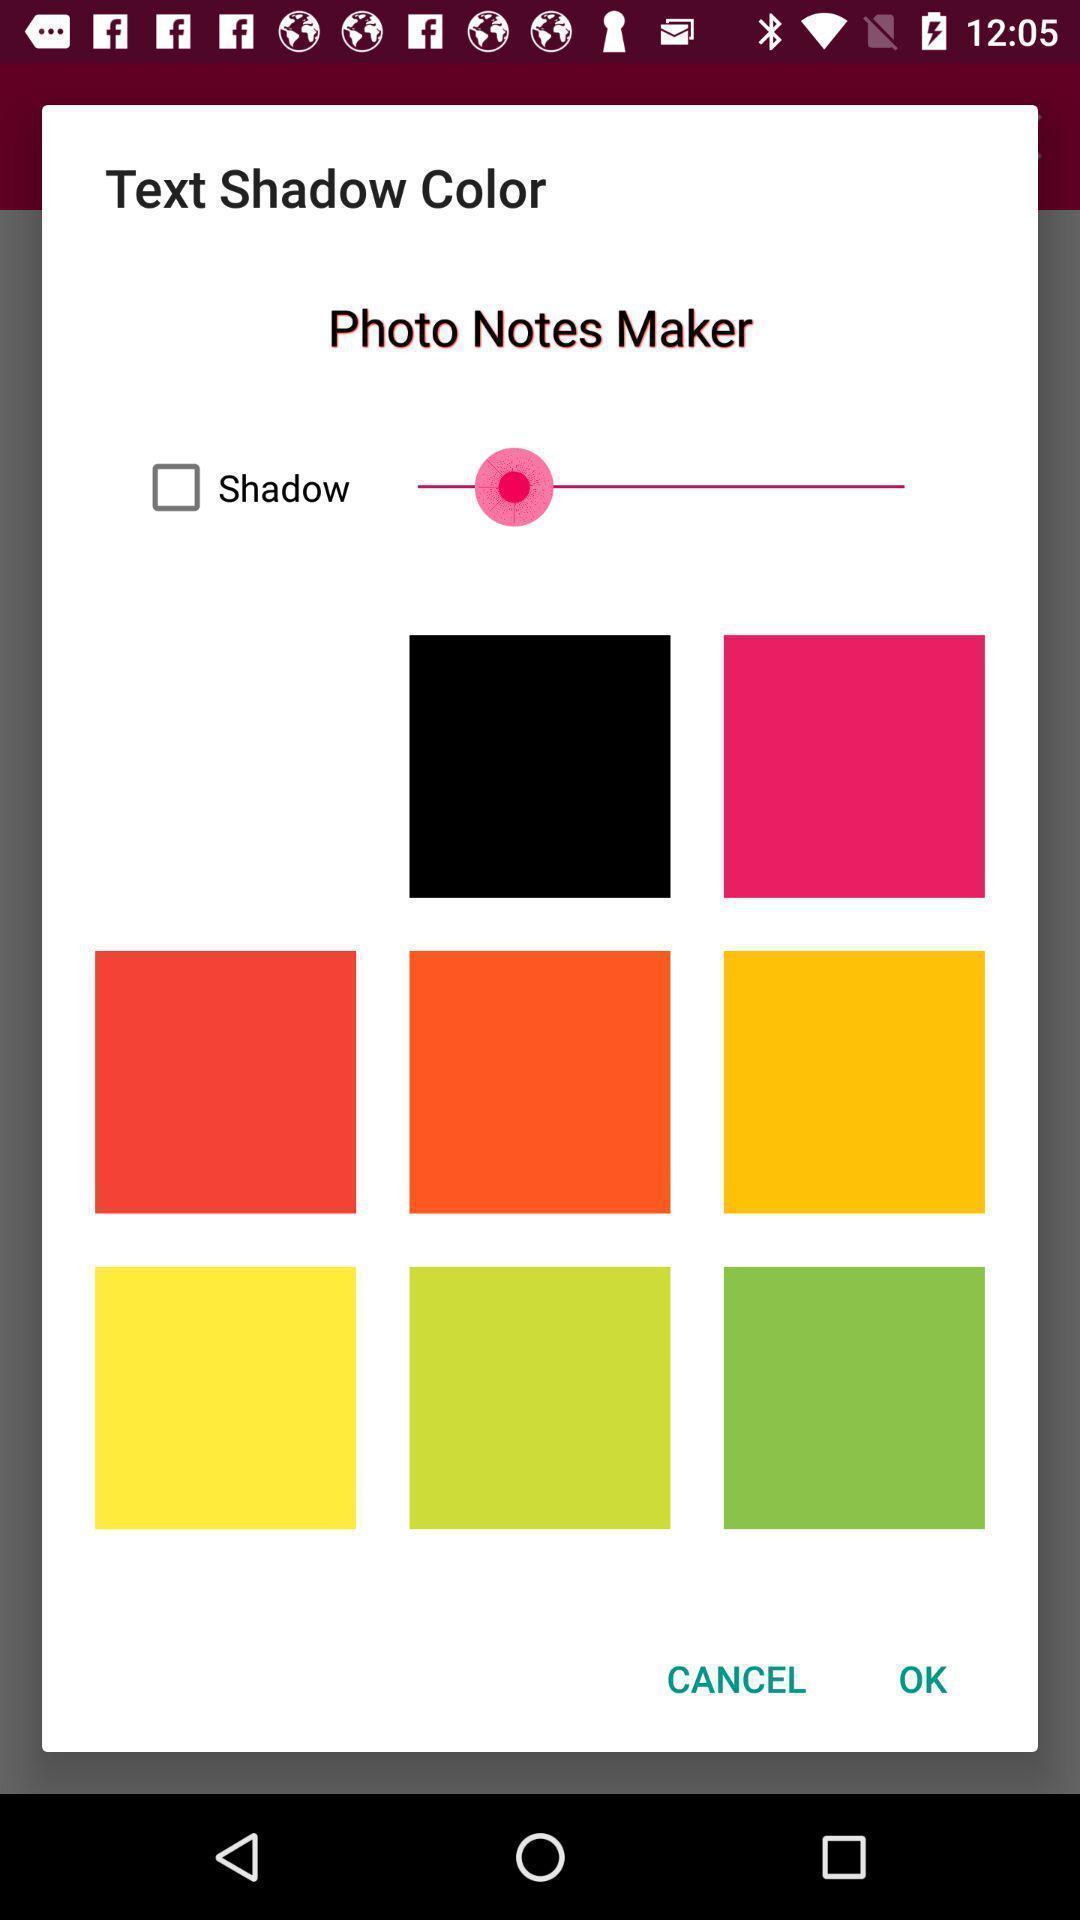Give me a summary of this screen capture. Popup showing about different color. 